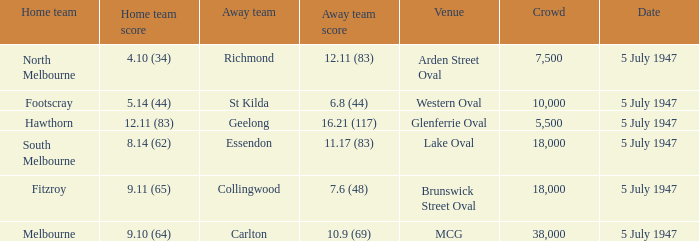What away team played against Footscray as the home team? St Kilda. 